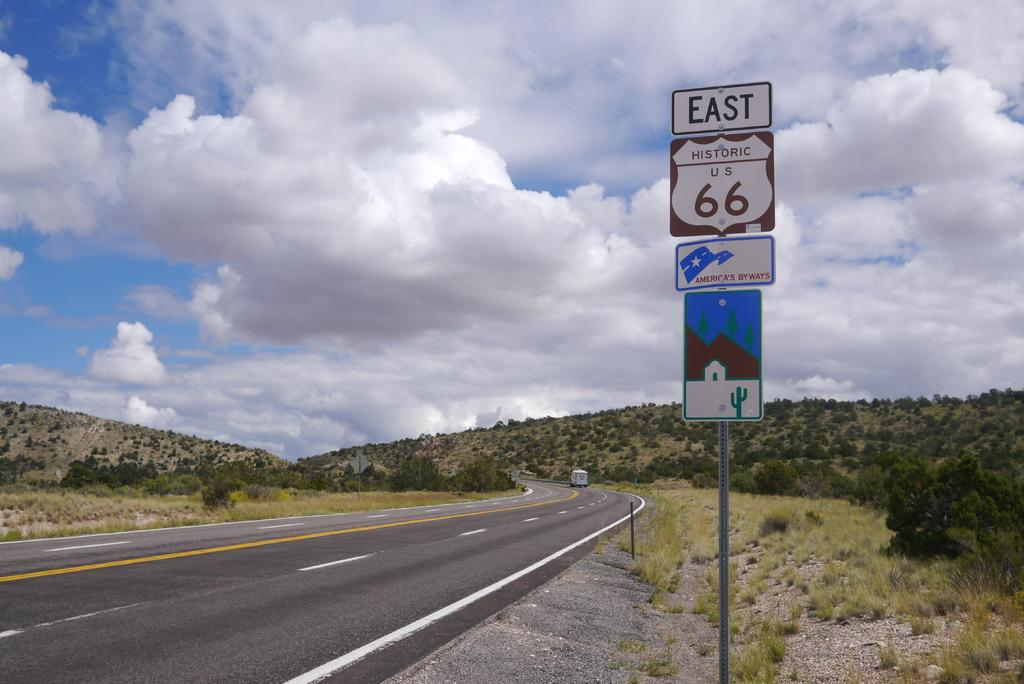Provide a one-sentence caption for the provided image. A nearly deserted highway with the word East and the number 66 on a sign. 